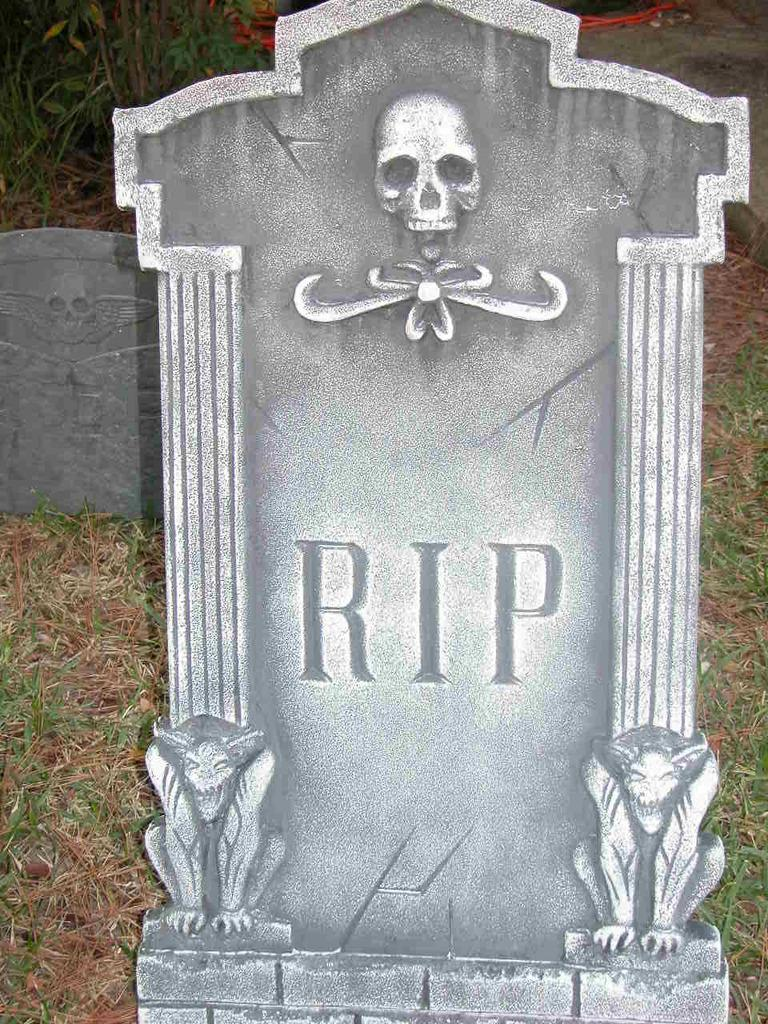How many cemeteries can be seen in the image? There are two cemeteries in the image. What type of terrain do the cemeteries occupy? The cemeteries are located on grassland. What can be found in the left top area of the image? There are plants in the left top area of the image. What is located in the right top area of the image? There is a rock in the right top area of the image. On what type of surface is the rock placed? The rock is on the grassland. What type of yoke is being used to carry the tin in the image? There is no yoke or tin present in the image; it features two cemeteries on grassland with plants and a rock. What is the rate of growth for the plants in the image? The provided facts do not include information about the rate of growth for the plants in the image. 